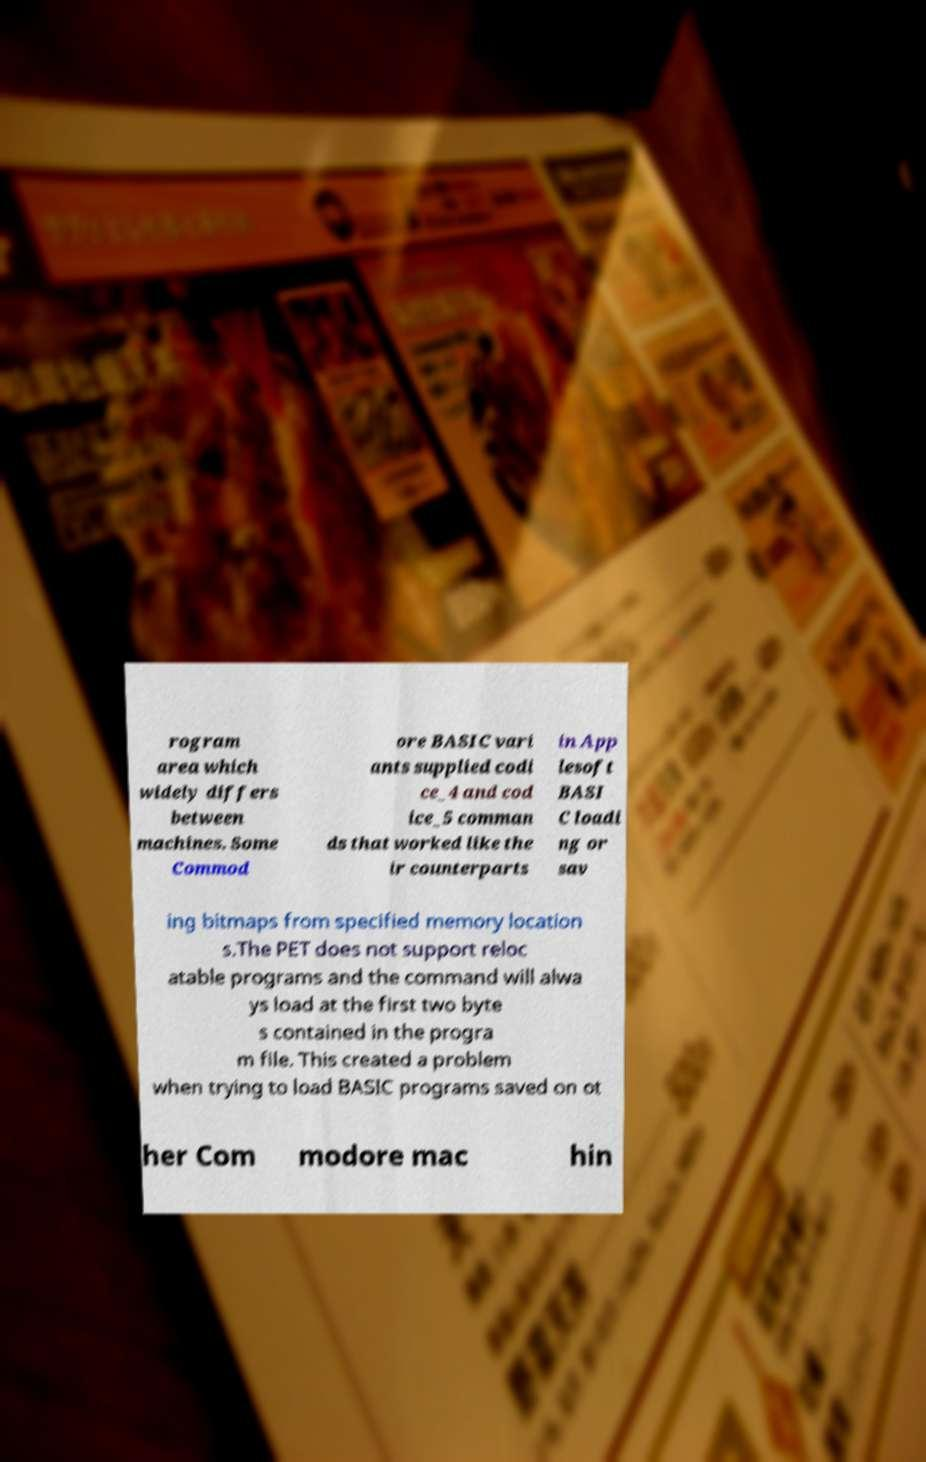Can you read and provide the text displayed in the image?This photo seems to have some interesting text. Can you extract and type it out for me? rogram area which widely differs between machines. Some Commod ore BASIC vari ants supplied codi ce_4 and cod ice_5 comman ds that worked like the ir counterparts in App lesoft BASI C loadi ng or sav ing bitmaps from specified memory location s.The PET does not support reloc atable programs and the command will alwa ys load at the first two byte s contained in the progra m file. This created a problem when trying to load BASIC programs saved on ot her Com modore mac hin 